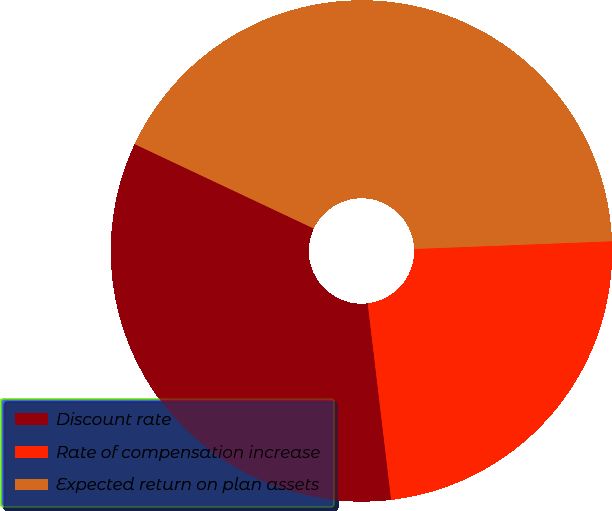Convert chart. <chart><loc_0><loc_0><loc_500><loc_500><pie_chart><fcel>Discount rate<fcel>Rate of compensation increase<fcel>Expected return on plan assets<nl><fcel>33.9%<fcel>23.73%<fcel>42.37%<nl></chart> 